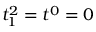<formula> <loc_0><loc_0><loc_500><loc_500>t _ { 1 } ^ { 2 } = t ^ { 0 } = 0</formula> 